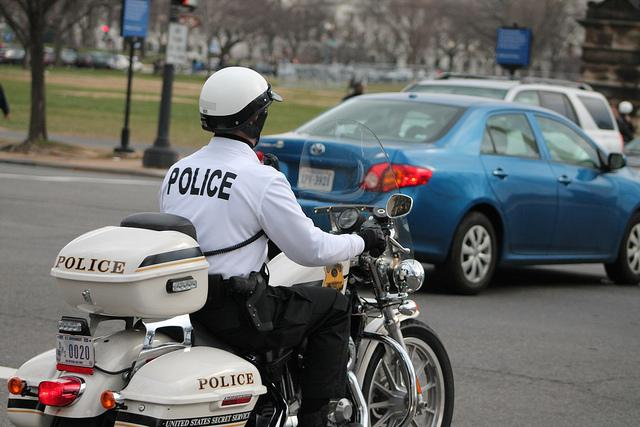The Harley police bikes are iconic bikes of police force in?

Choices:
A) uk
B) australia
C) france
D) us us 